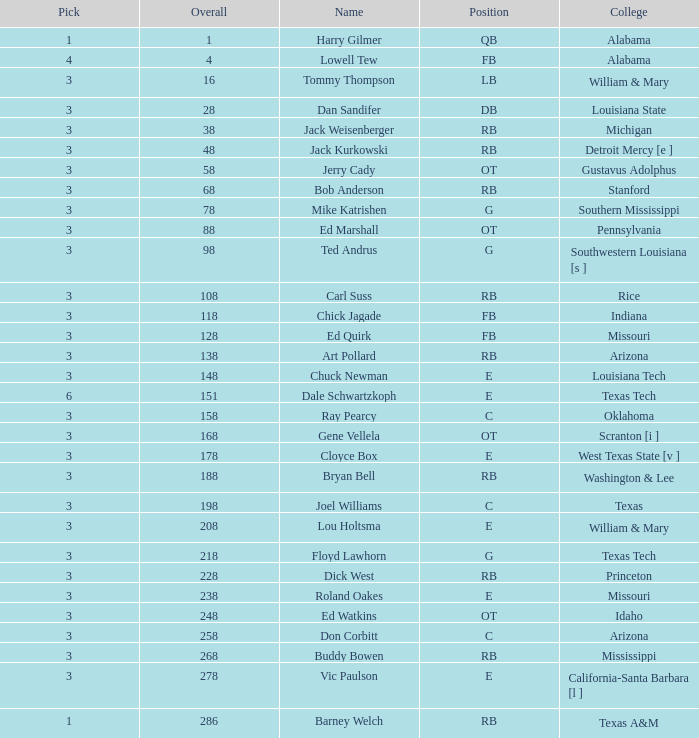What is the overall average for stanford? 68.0. 